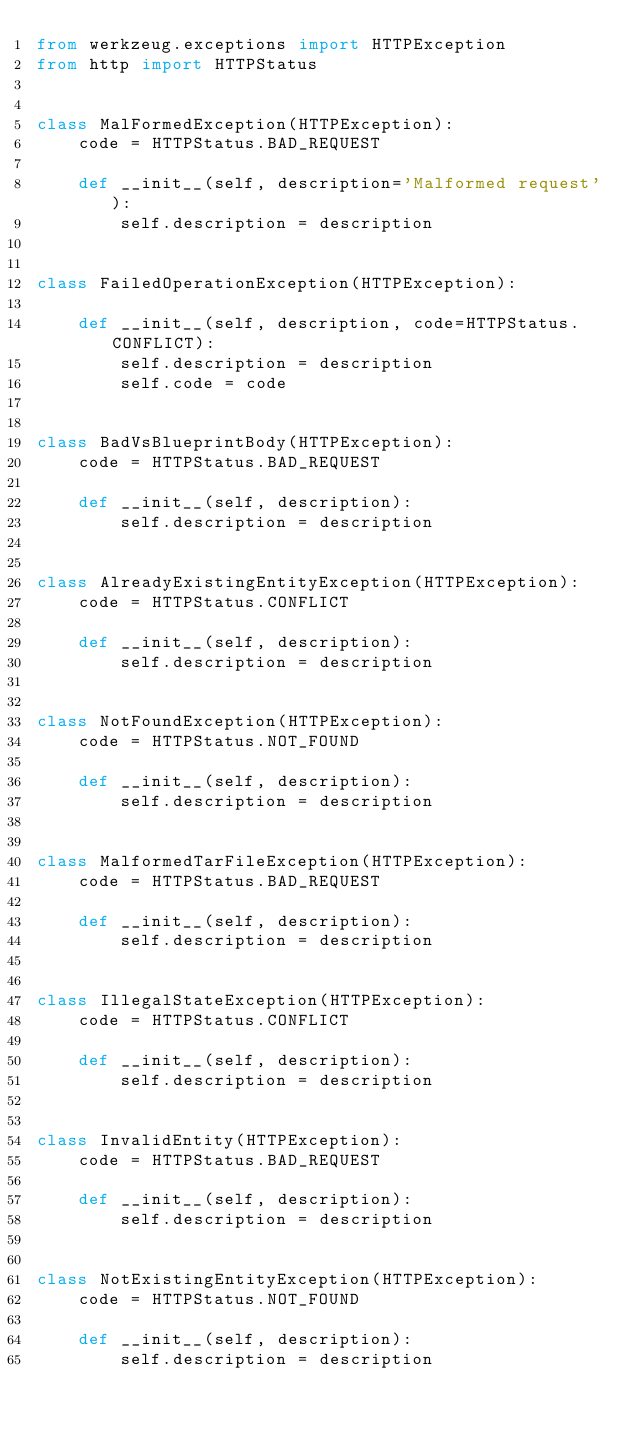<code> <loc_0><loc_0><loc_500><loc_500><_Python_>from werkzeug.exceptions import HTTPException
from http import HTTPStatus


class MalFormedException(HTTPException):
    code = HTTPStatus.BAD_REQUEST

    def __init__(self, description='Malformed request'):
        self.description = description


class FailedOperationException(HTTPException):

    def __init__(self, description, code=HTTPStatus.CONFLICT):
        self.description = description
        self.code = code


class BadVsBlueprintBody(HTTPException):
    code = HTTPStatus.BAD_REQUEST

    def __init__(self, description):
        self.description = description


class AlreadyExistingEntityException(HTTPException):
    code = HTTPStatus.CONFLICT

    def __init__(self, description):
        self.description = description


class NotFoundException(HTTPException):
    code = HTTPStatus.NOT_FOUND

    def __init__(self, description):
        self.description = description


class MalformedTarFileException(HTTPException):
    code = HTTPStatus.BAD_REQUEST

    def __init__(self, description):
        self.description = description


class IllegalStateException(HTTPException):
    code = HTTPStatus.CONFLICT

    def __init__(self, description):
        self.description = description


class InvalidEntity(HTTPException):
    code = HTTPStatus.BAD_REQUEST

    def __init__(self, description):
        self.description = description


class NotExistingEntityException(HTTPException):
    code = HTTPStatus.NOT_FOUND

    def __init__(self, description):
        self.description = description
</code> 